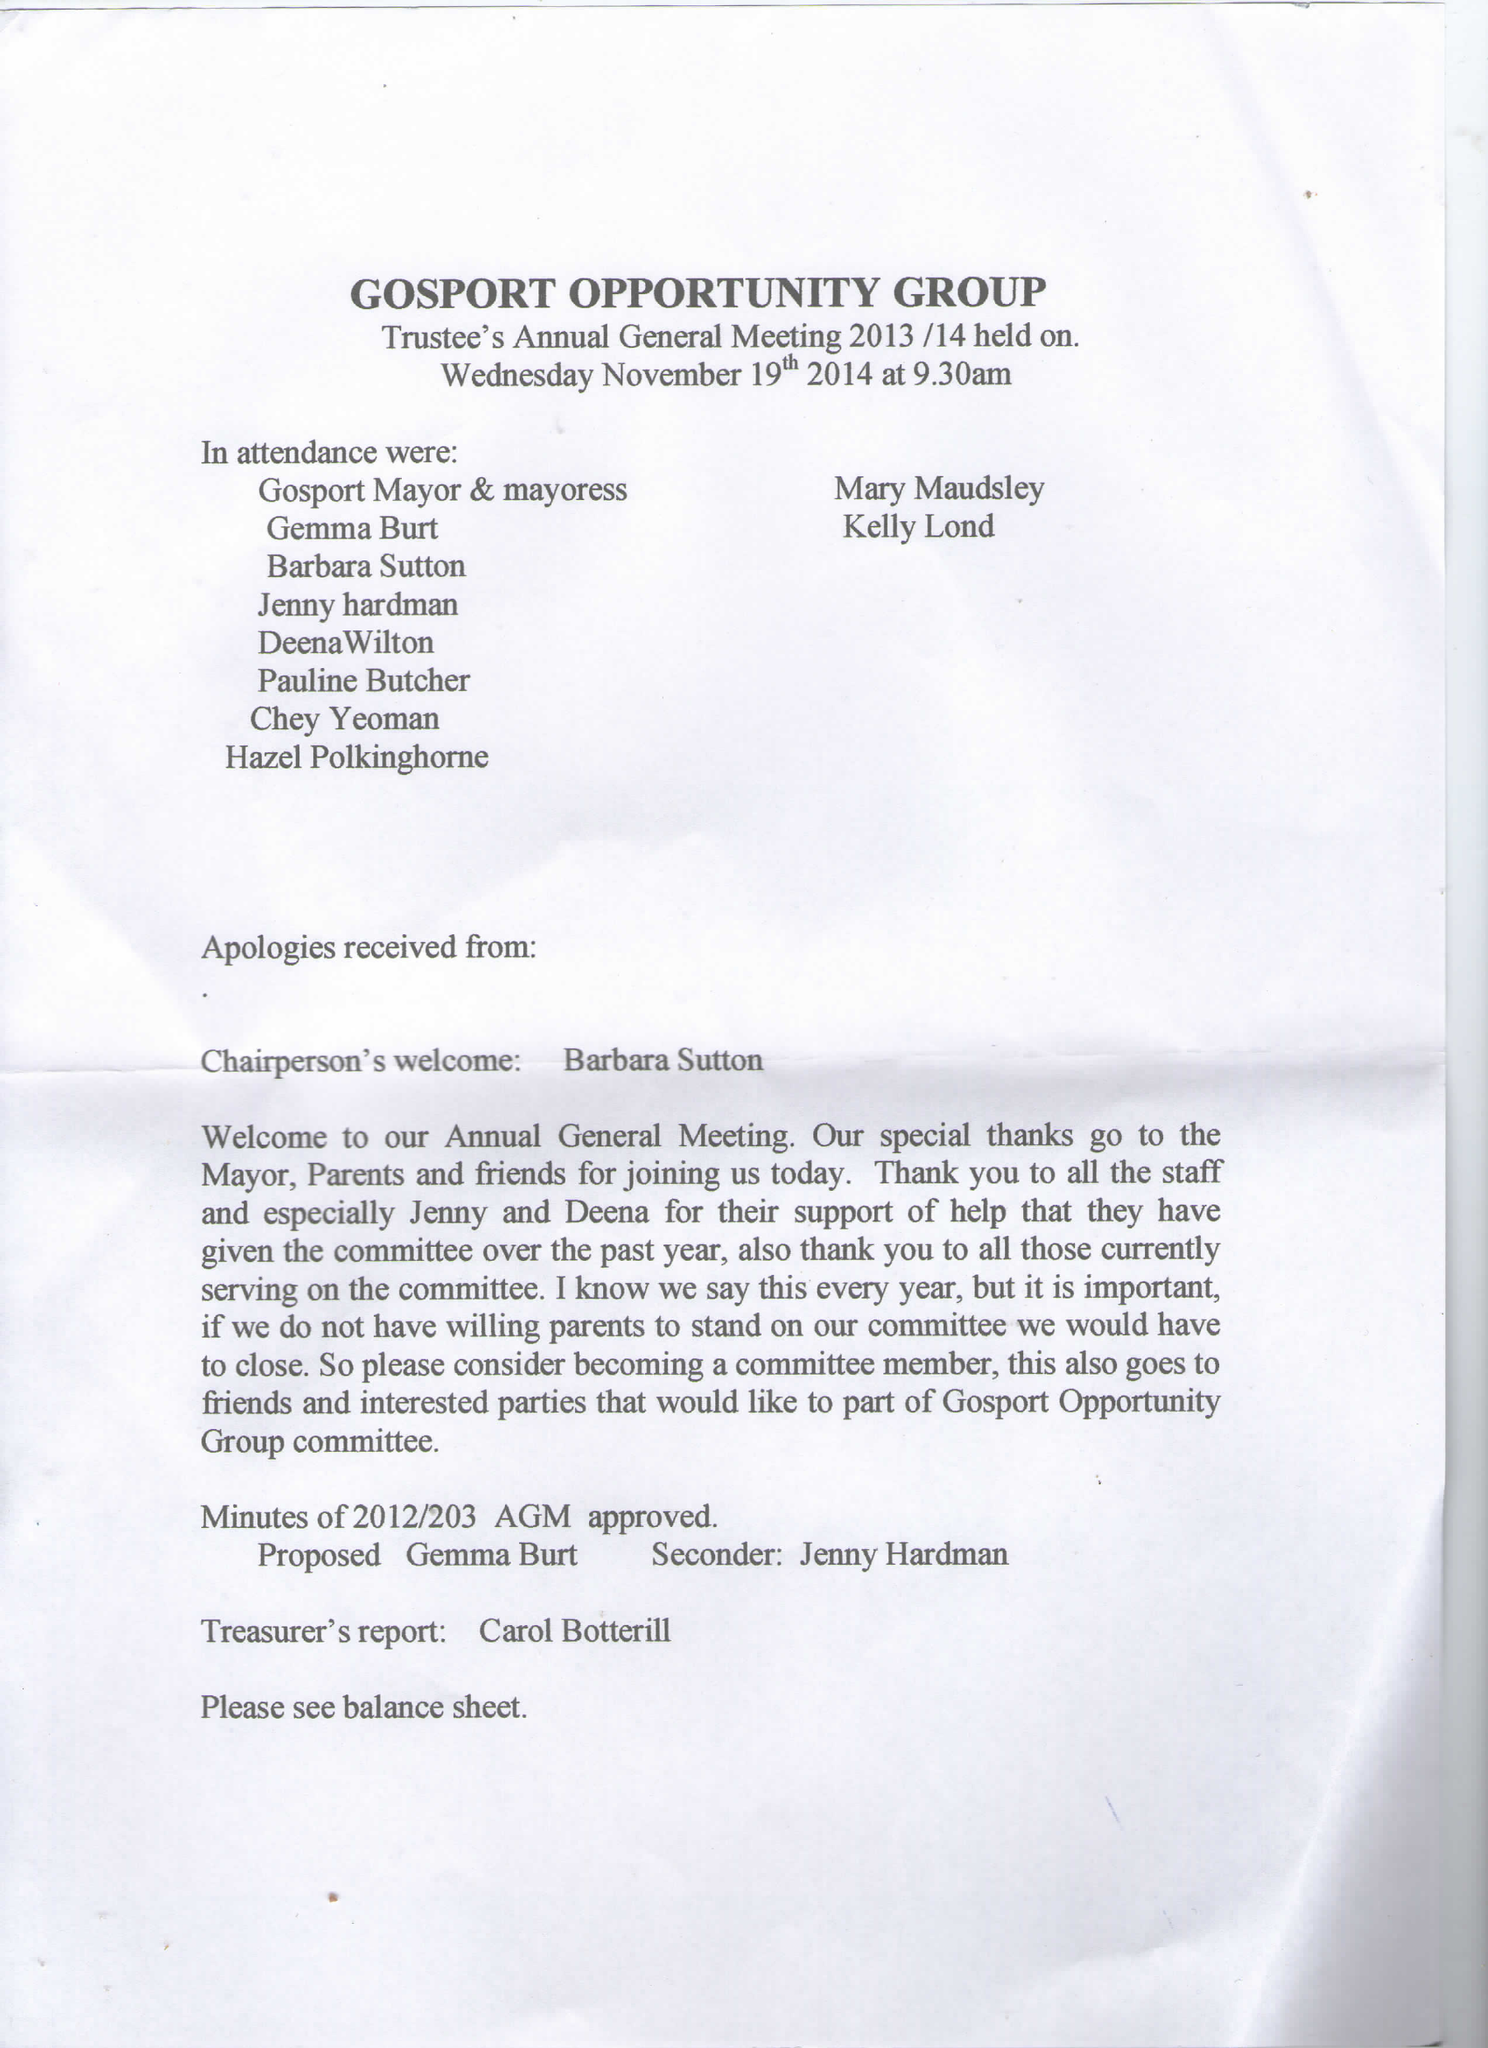What is the value for the charity_name?
Answer the question using a single word or phrase. Gosport Opportunity Group 